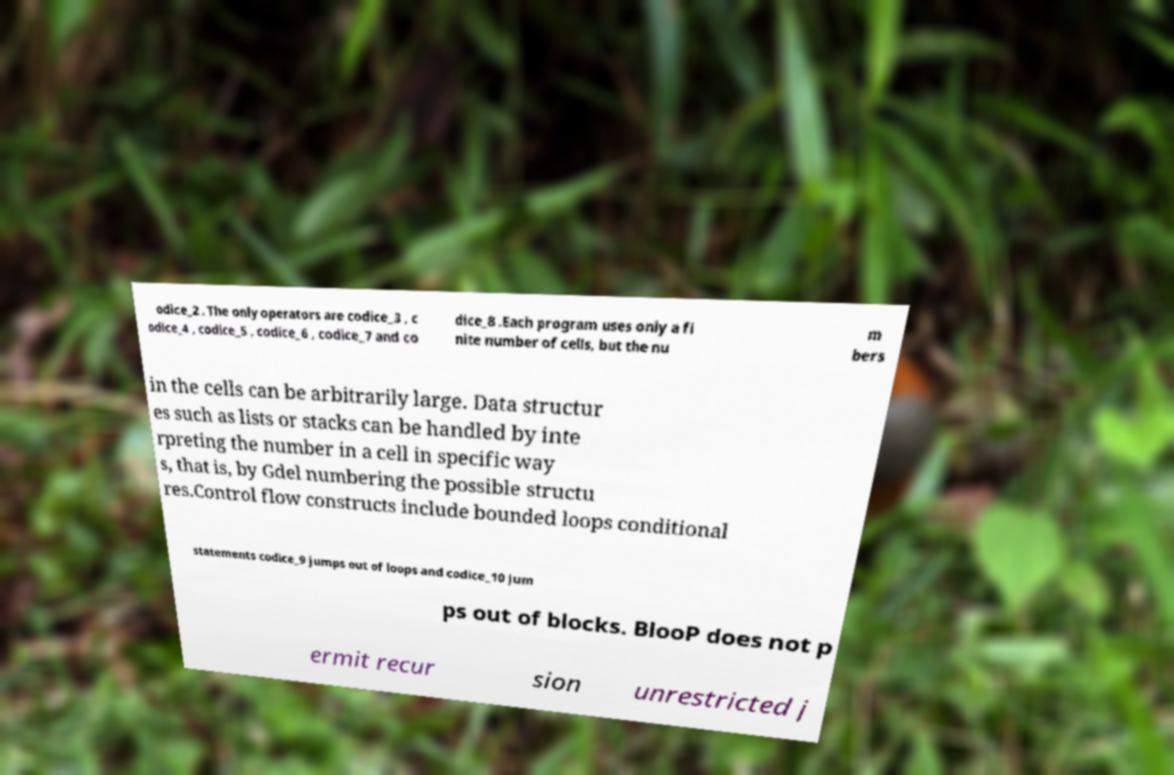There's text embedded in this image that I need extracted. Can you transcribe it verbatim? odice_2 . The only operators are codice_3 , c odice_4 , codice_5 , codice_6 , codice_7 and co dice_8 .Each program uses only a fi nite number of cells, but the nu m bers in the cells can be arbitrarily large. Data structur es such as lists or stacks can be handled by inte rpreting the number in a cell in specific way s, that is, by Gdel numbering the possible structu res.Control flow constructs include bounded loops conditional statements codice_9 jumps out of loops and codice_10 jum ps out of blocks. BlooP does not p ermit recur sion unrestricted j 